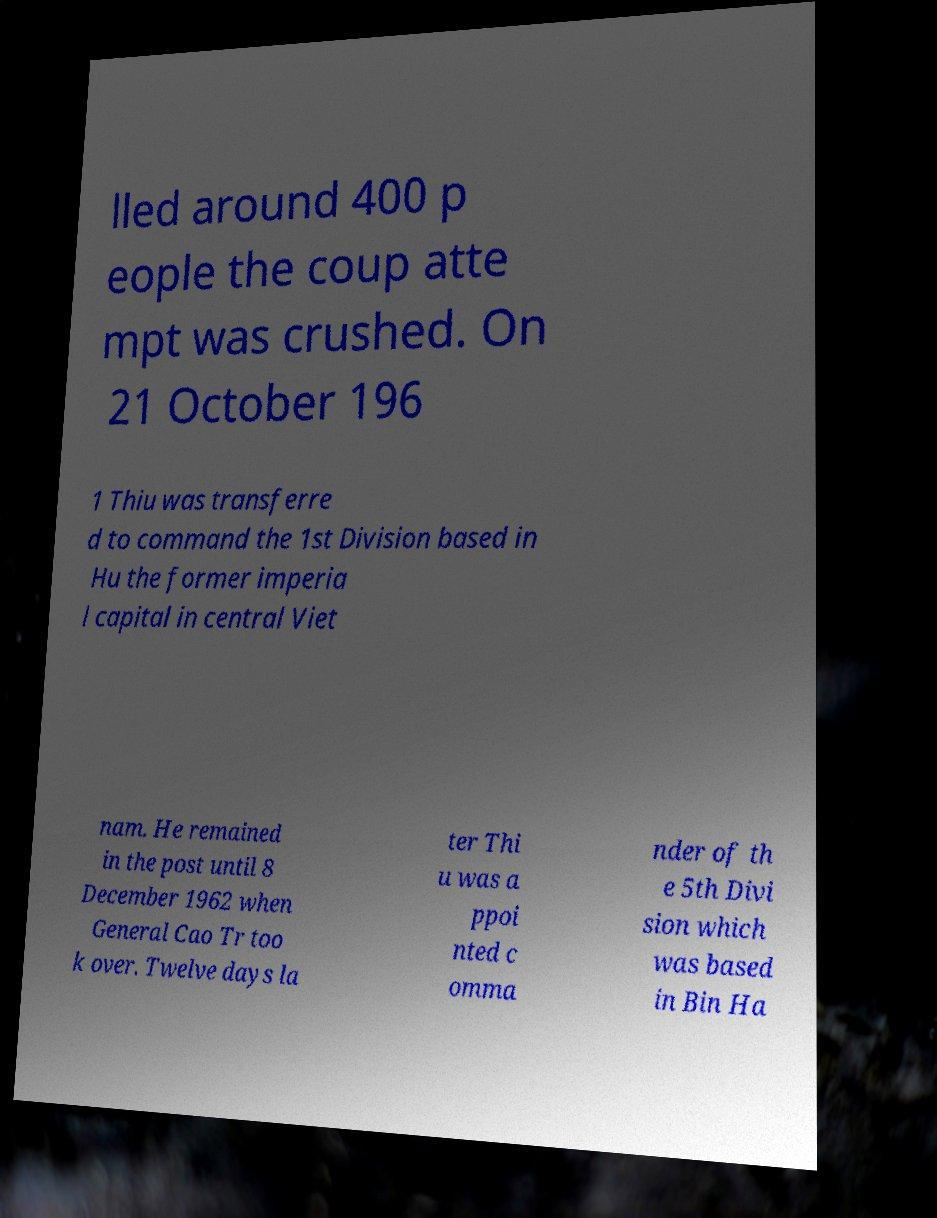Can you read and provide the text displayed in the image?This photo seems to have some interesting text. Can you extract and type it out for me? lled around 400 p eople the coup atte mpt was crushed. On 21 October 196 1 Thiu was transferre d to command the 1st Division based in Hu the former imperia l capital in central Viet nam. He remained in the post until 8 December 1962 when General Cao Tr too k over. Twelve days la ter Thi u was a ppoi nted c omma nder of th e 5th Divi sion which was based in Bin Ha 